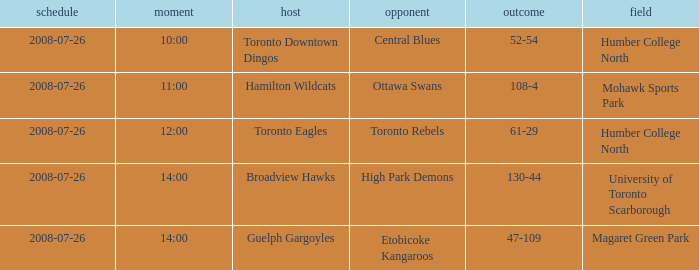When did the High Park Demons play Away? 2008-07-26. 